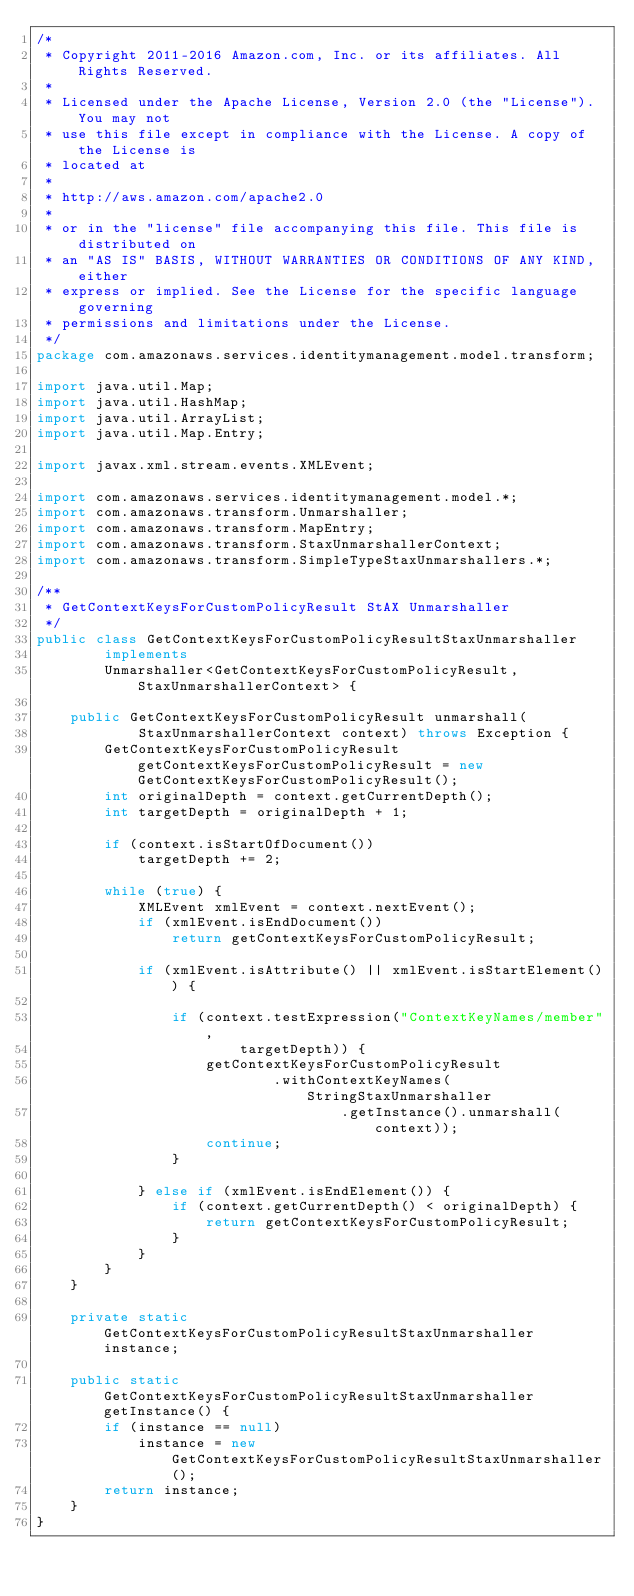<code> <loc_0><loc_0><loc_500><loc_500><_Java_>/*
 * Copyright 2011-2016 Amazon.com, Inc. or its affiliates. All Rights Reserved.
 * 
 * Licensed under the Apache License, Version 2.0 (the "License"). You may not
 * use this file except in compliance with the License. A copy of the License is
 * located at
 * 
 * http://aws.amazon.com/apache2.0
 * 
 * or in the "license" file accompanying this file. This file is distributed on
 * an "AS IS" BASIS, WITHOUT WARRANTIES OR CONDITIONS OF ANY KIND, either
 * express or implied. See the License for the specific language governing
 * permissions and limitations under the License.
 */
package com.amazonaws.services.identitymanagement.model.transform;

import java.util.Map;
import java.util.HashMap;
import java.util.ArrayList;
import java.util.Map.Entry;

import javax.xml.stream.events.XMLEvent;

import com.amazonaws.services.identitymanagement.model.*;
import com.amazonaws.transform.Unmarshaller;
import com.amazonaws.transform.MapEntry;
import com.amazonaws.transform.StaxUnmarshallerContext;
import com.amazonaws.transform.SimpleTypeStaxUnmarshallers.*;

/**
 * GetContextKeysForCustomPolicyResult StAX Unmarshaller
 */
public class GetContextKeysForCustomPolicyResultStaxUnmarshaller
        implements
        Unmarshaller<GetContextKeysForCustomPolicyResult, StaxUnmarshallerContext> {

    public GetContextKeysForCustomPolicyResult unmarshall(
            StaxUnmarshallerContext context) throws Exception {
        GetContextKeysForCustomPolicyResult getContextKeysForCustomPolicyResult = new GetContextKeysForCustomPolicyResult();
        int originalDepth = context.getCurrentDepth();
        int targetDepth = originalDepth + 1;

        if (context.isStartOfDocument())
            targetDepth += 2;

        while (true) {
            XMLEvent xmlEvent = context.nextEvent();
            if (xmlEvent.isEndDocument())
                return getContextKeysForCustomPolicyResult;

            if (xmlEvent.isAttribute() || xmlEvent.isStartElement()) {

                if (context.testExpression("ContextKeyNames/member",
                        targetDepth)) {
                    getContextKeysForCustomPolicyResult
                            .withContextKeyNames(StringStaxUnmarshaller
                                    .getInstance().unmarshall(context));
                    continue;
                }

            } else if (xmlEvent.isEndElement()) {
                if (context.getCurrentDepth() < originalDepth) {
                    return getContextKeysForCustomPolicyResult;
                }
            }
        }
    }

    private static GetContextKeysForCustomPolicyResultStaxUnmarshaller instance;

    public static GetContextKeysForCustomPolicyResultStaxUnmarshaller getInstance() {
        if (instance == null)
            instance = new GetContextKeysForCustomPolicyResultStaxUnmarshaller();
        return instance;
    }
}
</code> 